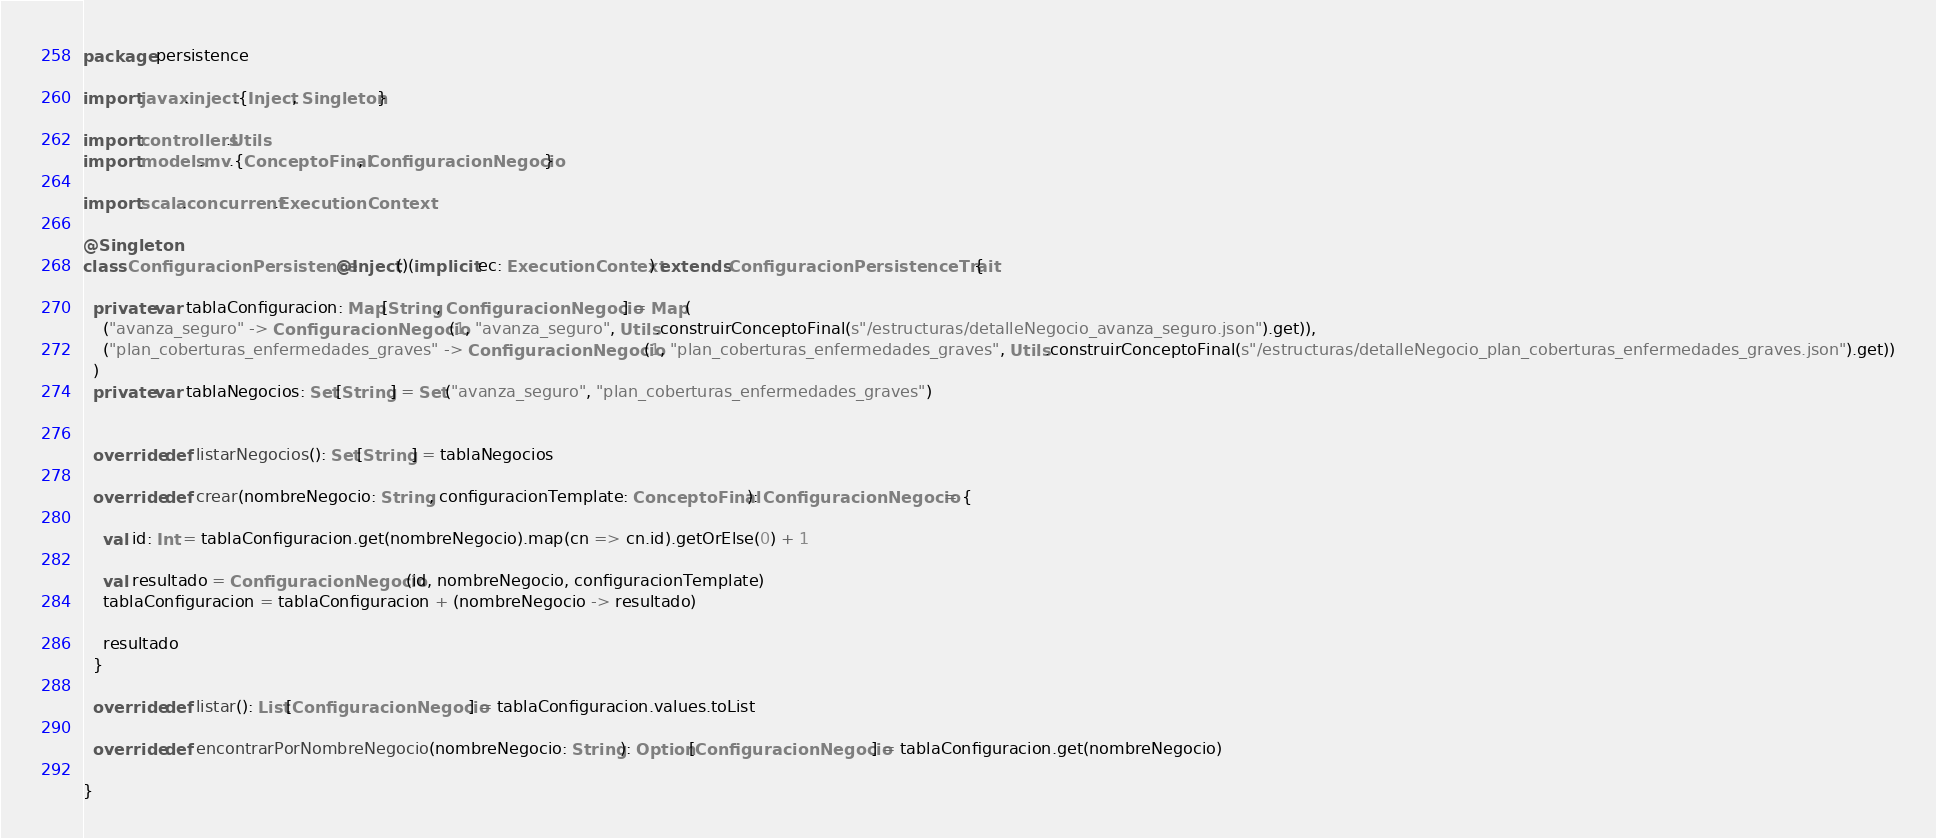<code> <loc_0><loc_0><loc_500><loc_500><_Scala_>package persistence

import javax.inject.{Inject, Singleton}

import controllers.Utils
import models.mv.{ConceptoFinal, ConfiguracionNegocio}

import scala.concurrent.ExecutionContext

@Singleton
class ConfiguracionPersistence @Inject()(implicit ec: ExecutionContext) extends ConfiguracionPersistenceTrait {

  private var tablaConfiguracion: Map[String, ConfiguracionNegocio] = Map(
    ("avanza_seguro" -> ConfiguracionNegocio(1, "avanza_seguro", Utils.construirConceptoFinal(s"/estructuras/detalleNegocio_avanza_seguro.json").get)),
    ("plan_coberturas_enfermedades_graves" -> ConfiguracionNegocio(1, "plan_coberturas_enfermedades_graves", Utils.construirConceptoFinal(s"/estructuras/detalleNegocio_plan_coberturas_enfermedades_graves.json").get))
  )
  private var tablaNegocios: Set[String] = Set("avanza_seguro", "plan_coberturas_enfermedades_graves")


  override def listarNegocios(): Set[String] = tablaNegocios

  override def crear(nombreNegocio: String, configuracionTemplate: ConceptoFinal): ConfiguracionNegocio = {

    val id: Int = tablaConfiguracion.get(nombreNegocio).map(cn => cn.id).getOrElse(0) + 1

    val resultado = ConfiguracionNegocio(id, nombreNegocio, configuracionTemplate)
    tablaConfiguracion = tablaConfiguracion + (nombreNegocio -> resultado)

    resultado
  }

  override def listar(): List[ConfiguracionNegocio] = tablaConfiguracion.values.toList

  override def encontrarPorNombreNegocio(nombreNegocio: String): Option[ConfiguracionNegocio] = tablaConfiguracion.get(nombreNegocio)

}
</code> 